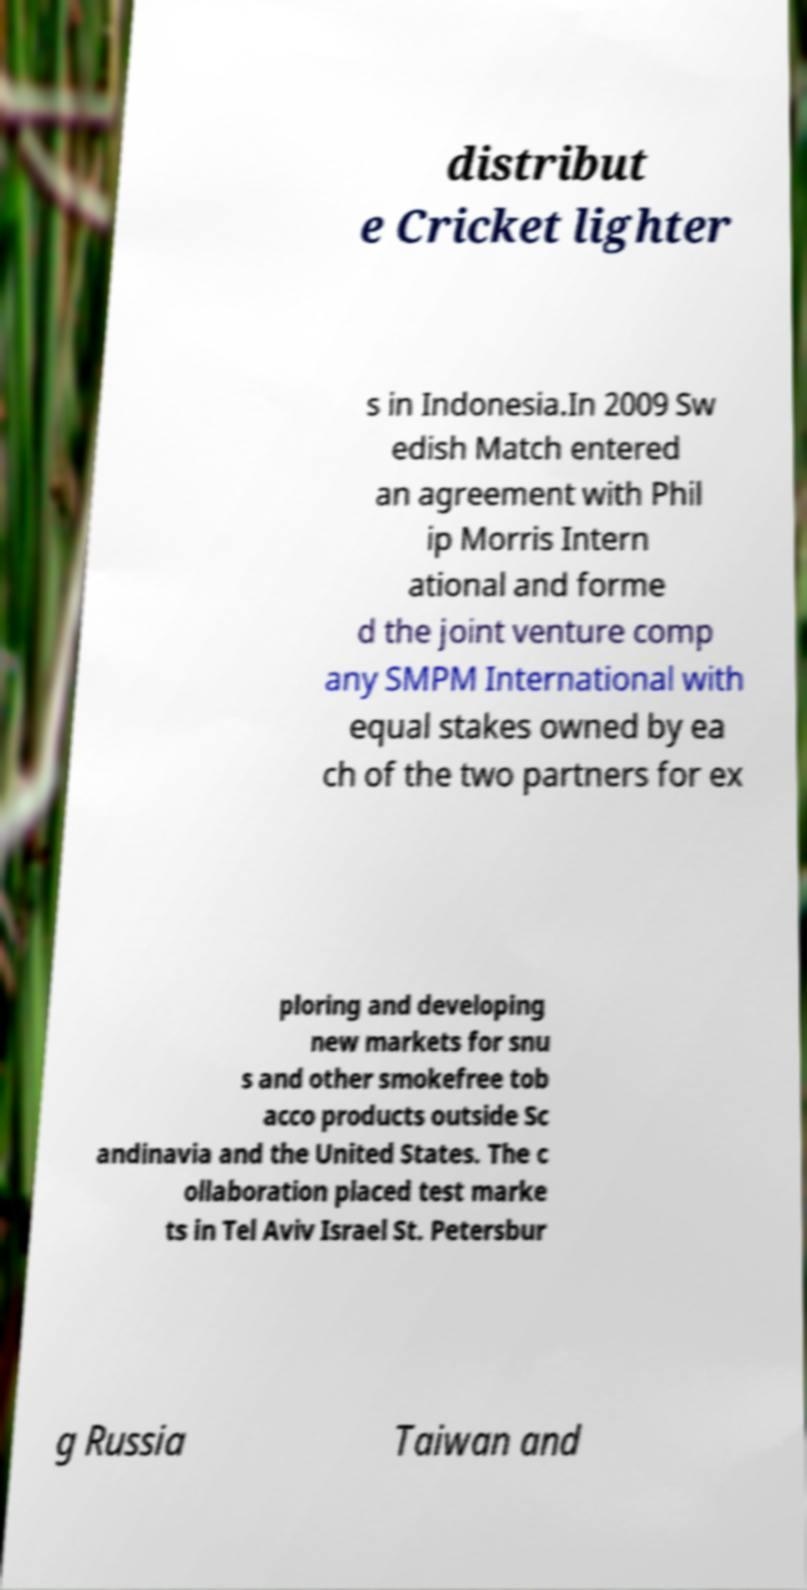Please identify and transcribe the text found in this image. distribut e Cricket lighter s in Indonesia.In 2009 Sw edish Match entered an agreement with Phil ip Morris Intern ational and forme d the joint venture comp any SMPM International with equal stakes owned by ea ch of the two partners for ex ploring and developing new markets for snu s and other smokefree tob acco products outside Sc andinavia and the United States. The c ollaboration placed test marke ts in Tel Aviv Israel St. Petersbur g Russia Taiwan and 